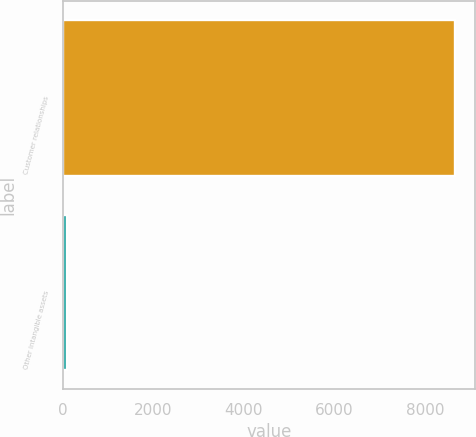<chart> <loc_0><loc_0><loc_500><loc_500><bar_chart><fcel>Customer relationships<fcel>Other intangible assets<nl><fcel>8664<fcel>92<nl></chart> 